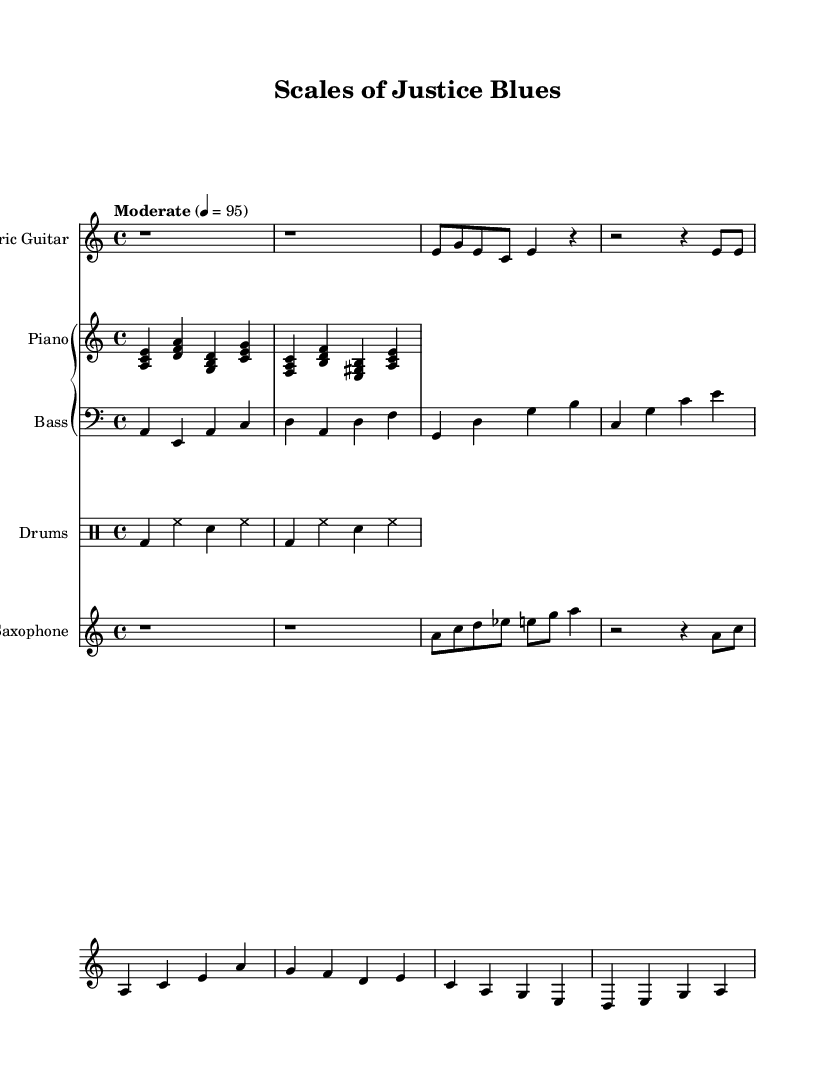What is the key signature of this music? The key signature is indicated by the "a" in the global block, meaning it is in A minor, which has no sharps or flats.
Answer: A minor What is the time signature of this piece? The time signature is shown as "4/4" in the global block, indicating that there are four beats in a measure and a quarter note receives one beat.
Answer: 4/4 What is the tempo marking for this music? The tempo marking is indicated as "Moderate" with the metronome marking of 4 = 95, suggesting a moderate pace of 95 beats per minute.
Answer: Moderate, 4 = 95 How many instruments are in this score? The score includes four distinct instruments: Electric Guitar, Piano (which consists of two staves – piano and bass), Drums, and Saxophone, totaling four.
Answer: Four Which instrument plays the melody in the first section? The Electric Guitar plays the melody in the first section, as it is the first staff listed and features the main melodic lines.
Answer: Electric Guitar Which chords are played by the piano in the first measure? The piano plays the chords A minor (a, c, e), D minor (d, f, a), G major (g, b, d), and C major (c, e, g) in the first measure.
Answer: A minor, D minor, G major, C major What genre is this piece classified under? The sheet music is indicated to be "Electric Blues", and it incorporates jazz elements, which blends the two genres creatively.
Answer: Electric Blues 